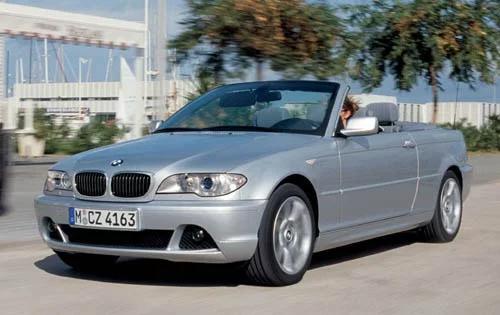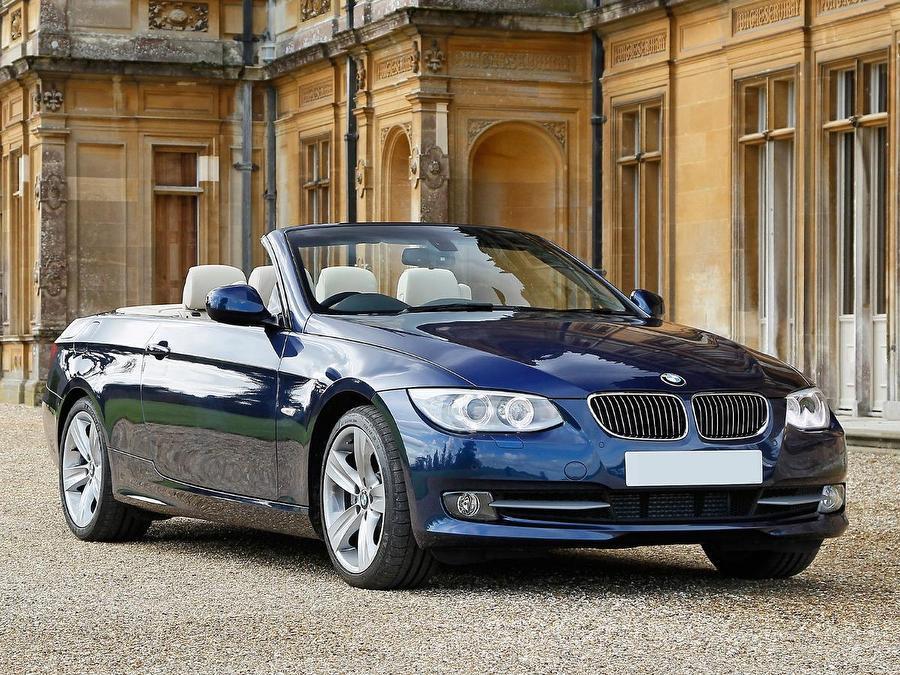The first image is the image on the left, the second image is the image on the right. For the images shown, is this caption "One convertible faces away from the camera, and the other is silver and facing rightward." true? Answer yes or no. No. The first image is the image on the left, the second image is the image on the right. Assess this claim about the two images: "An image has a blue convertible sports car.". Correct or not? Answer yes or no. Yes. 